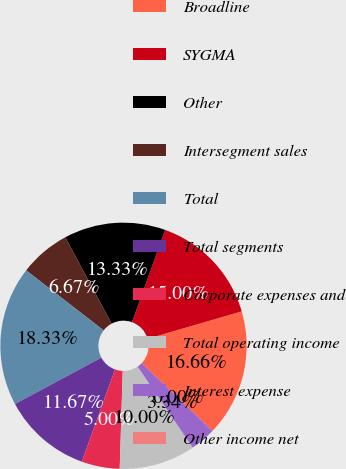Convert chart to OTSL. <chart><loc_0><loc_0><loc_500><loc_500><pie_chart><fcel>Broadline<fcel>SYGMA<fcel>Other<fcel>Intersegment sales<fcel>Total<fcel>Total segments<fcel>Corporate expenses and<fcel>Total operating income<fcel>Interest expense<fcel>Other income net<nl><fcel>16.66%<fcel>15.0%<fcel>13.33%<fcel>6.67%<fcel>18.33%<fcel>11.67%<fcel>5.0%<fcel>10.0%<fcel>3.34%<fcel>0.0%<nl></chart> 